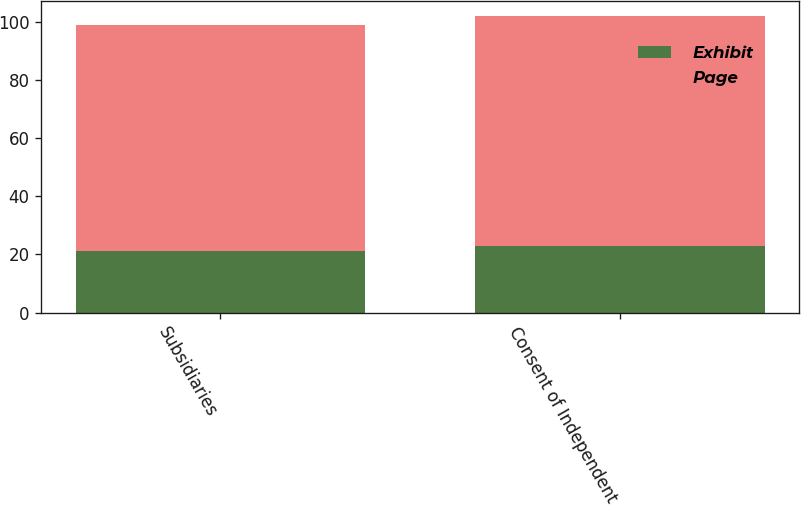Convert chart. <chart><loc_0><loc_0><loc_500><loc_500><stacked_bar_chart><ecel><fcel>Subsidiaries<fcel>Consent of Independent<nl><fcel>Exhibit<fcel>21<fcel>23<nl><fcel>Page<fcel>78<fcel>79<nl></chart> 